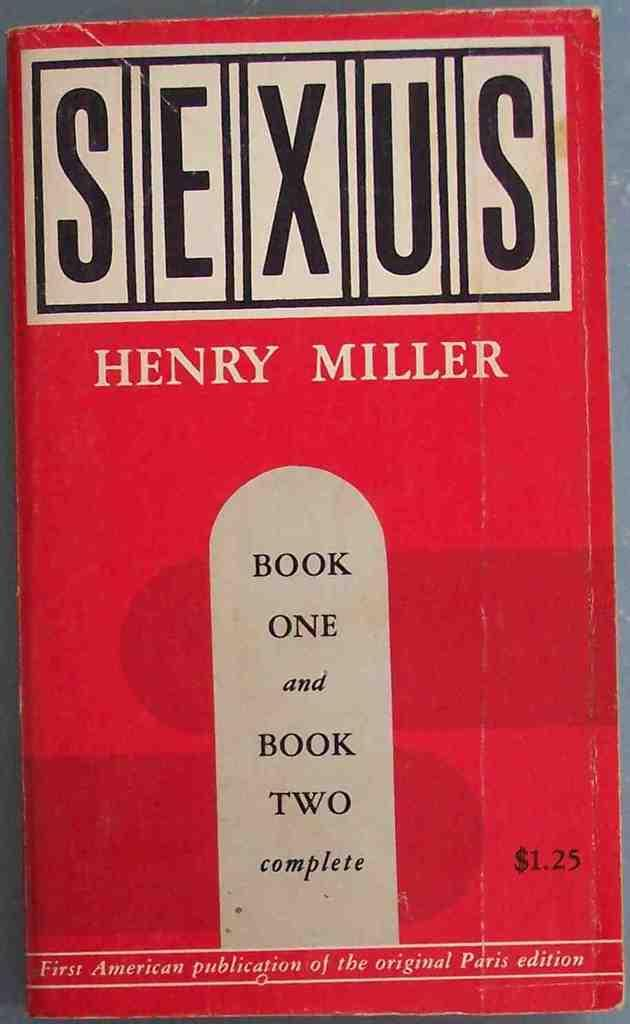<image>
Give a short and clear explanation of the subsequent image. A red book called Sexus by Henry Miller has a $1.25 price tag. 